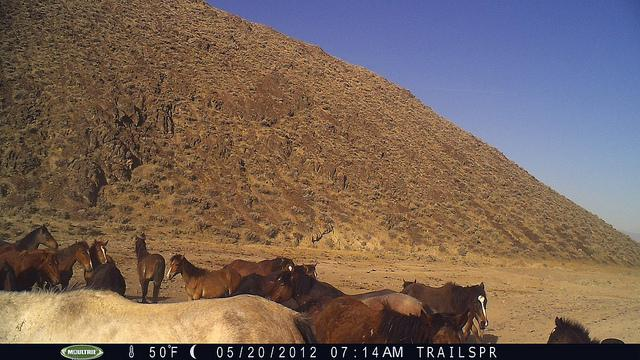What is the term used to call this group of horses? herd 